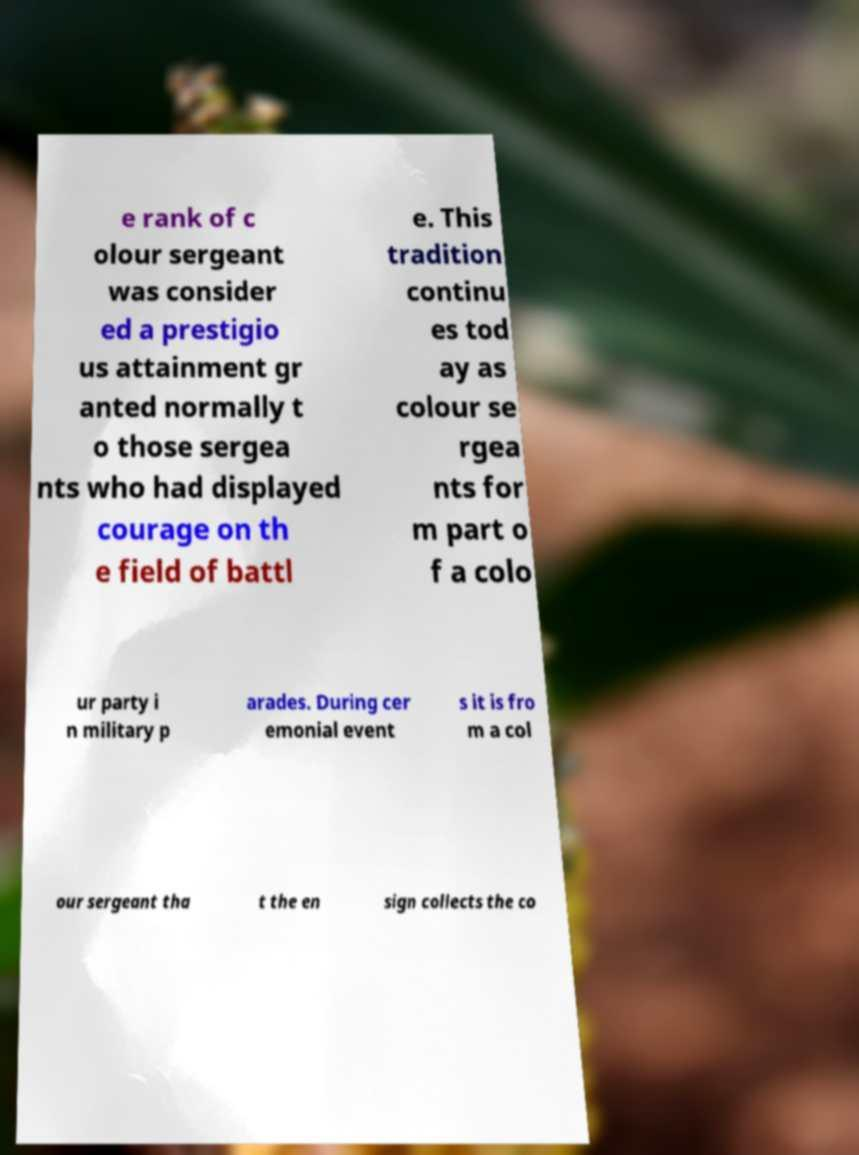There's text embedded in this image that I need extracted. Can you transcribe it verbatim? e rank of c olour sergeant was consider ed a prestigio us attainment gr anted normally t o those sergea nts who had displayed courage on th e field of battl e. This tradition continu es tod ay as colour se rgea nts for m part o f a colo ur party i n military p arades. During cer emonial event s it is fro m a col our sergeant tha t the en sign collects the co 